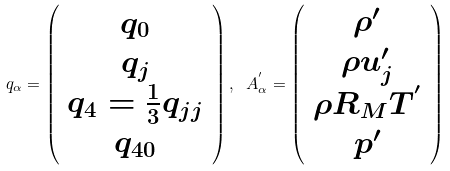Convert formula to latex. <formula><loc_0><loc_0><loc_500><loc_500>q _ { \alpha } = \left ( \begin{array} { c } q _ { 0 } \\ q _ { j } \\ q _ { 4 } = \frac { 1 } { 3 } q _ { j j } \\ q _ { 4 0 } \end{array} \right ) , \ A ^ { ^ { \prime } } _ { \alpha } = \left ( \begin{array} { c } \rho ^ { \prime } \\ \rho u _ { j } ^ { \prime } \\ \rho R _ { M } T ^ { ^ { \prime } } \\ p ^ { \prime } \end{array} \right )</formula> 